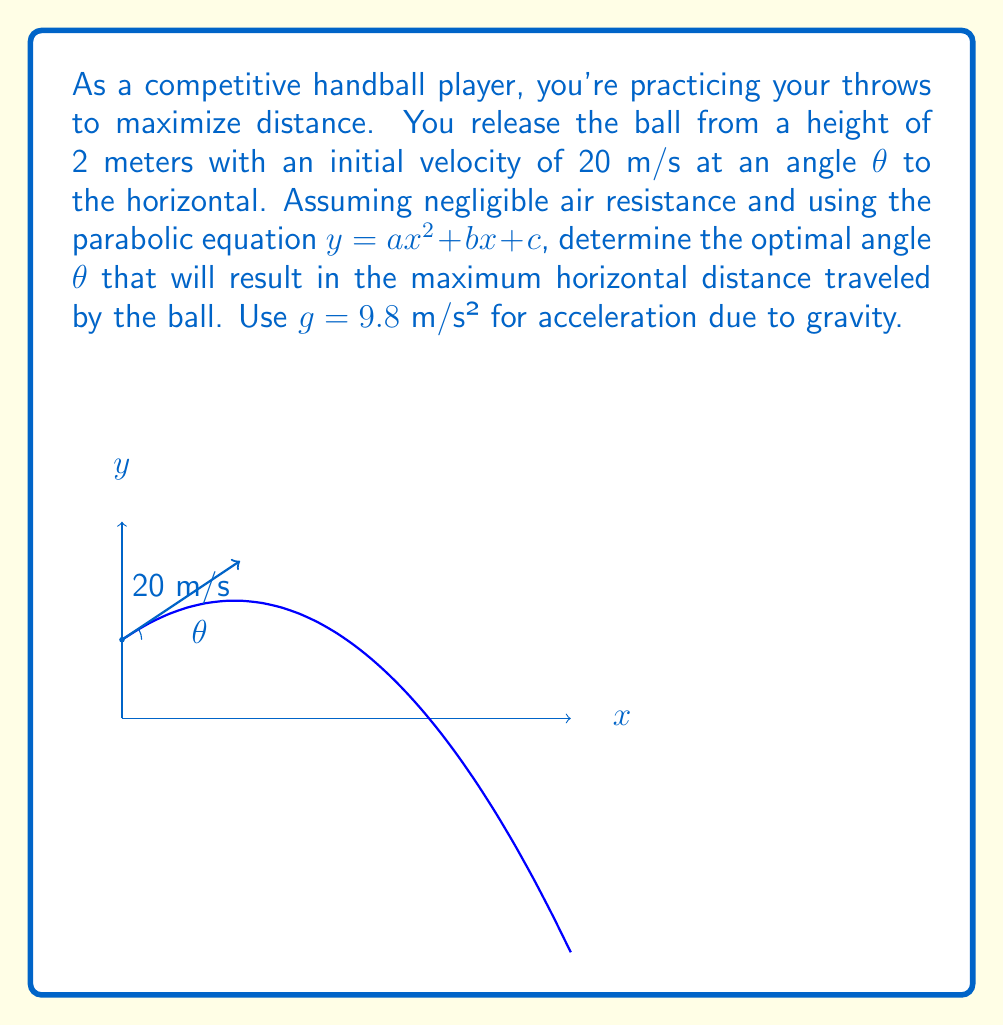Could you help me with this problem? Let's approach this step-by-step:

1) The parabolic equation for projectile motion is:

   $y = -\frac{1}{2}g(\frac{x}{v_0 \cos θ})^2 + (x \tan θ) + h$

   Where $g$ is gravity, $v_0$ is initial velocity, $θ$ is the launch angle, and $h$ is the initial height.

2) Comparing this to the standard form $y = ax^2 + bx + c$, we can identify:

   $a = -\frac{g}{2(v_0 \cos θ)^2}$
   $b = \tan θ$
   $c = h = 2$

3) The horizontal distance (range) $R$ is given by:

   $R = \frac{v_0^2}{g}(\sin 2θ + \sqrt{\sin^2 2θ + \frac{2gh}{v_0^2}})$

4) To find the maximum range, we need to differentiate $R$ with respect to θ and set it to zero. However, this leads to a complex equation.

5) For a simpler approach, we can use the fact that without considering the initial height, the optimal angle would be 45°. With a non-zero initial height, the optimal angle is slightly less than 45°.

6) We can use an approximation formula for the optimal angle:

   $θ_{opt} ≈ 45° - \frac{1}{2}\arcsin(\frac{gh}{v_0^2})$

7) Plugging in our values:

   $θ_{opt} ≈ 45° - \frac{1}{2}\arcsin(\frac{9.8 * 2}{20^2}) ≈ 45° - 2.8° = 42.2°$

8) To verify, we could calculate the range for angles close to this value and confirm it gives the maximum distance.
Answer: $θ_{opt} ≈ 42.2°$ 